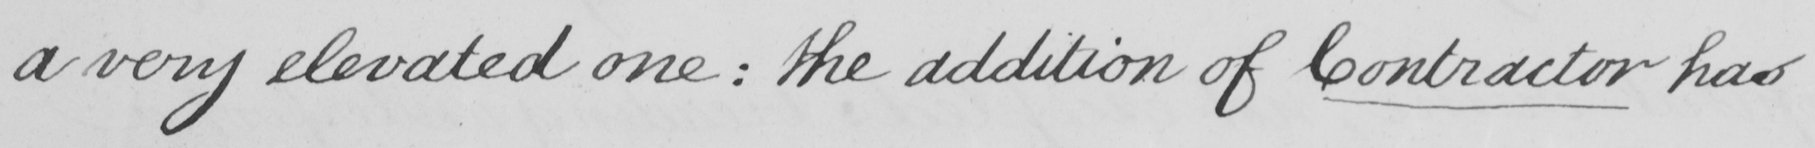What text is written in this handwritten line? a very elevated one :  the addition of Contractor has 